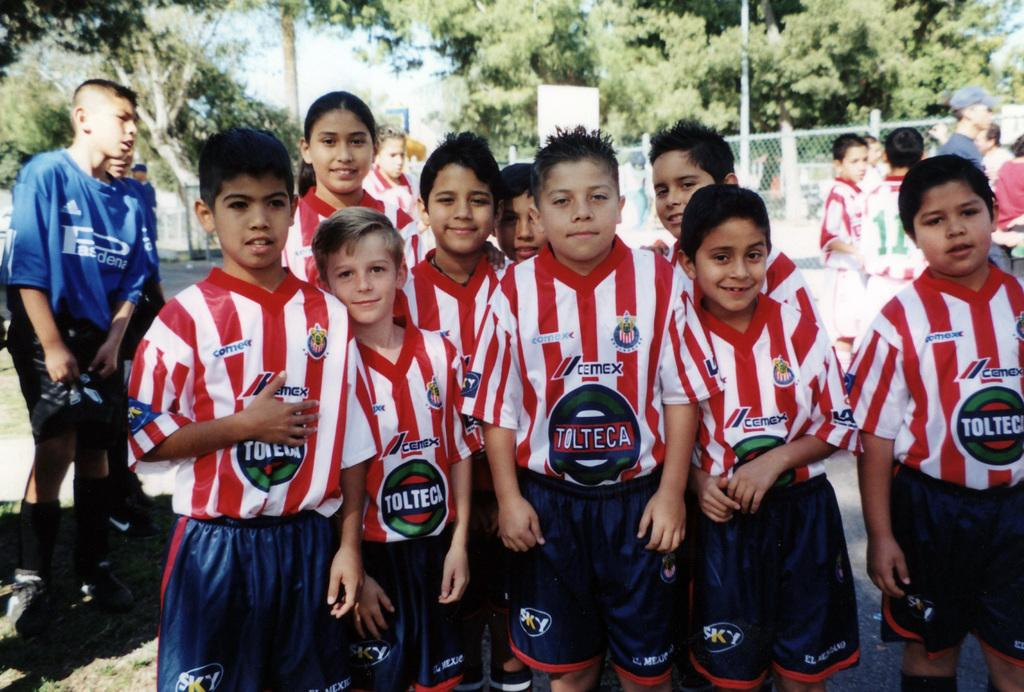<image>
Offer a succinct explanation of the picture presented. a few players that are wearing Tolteca on it 